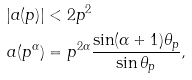Convert formula to latex. <formula><loc_0><loc_0><loc_500><loc_500>| a ( p ) | & < 2 p ^ { 2 } \\ a ( p ^ { \alpha } ) & = p ^ { 2 \alpha } \frac { \sin ( \alpha + 1 ) \theta _ { p } } { \sin \theta _ { p } } ,</formula> 